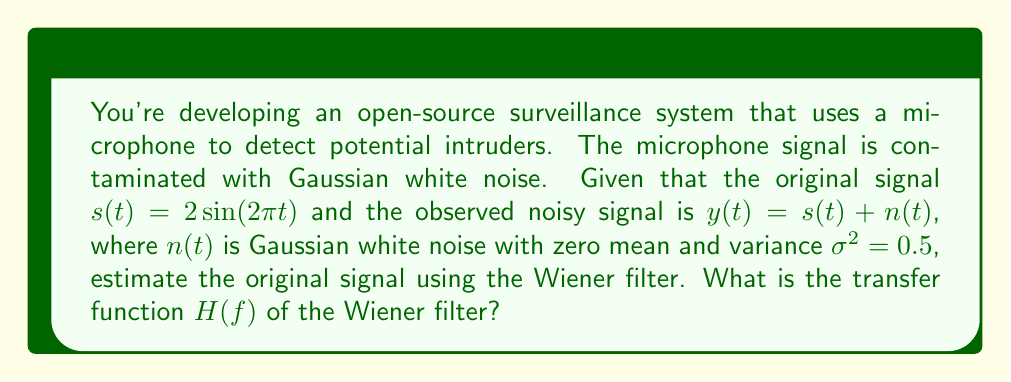Provide a solution to this math problem. To estimate the original signal from noisy sensor data using the Wiener filter, we follow these steps:

1. The Wiener filter's transfer function is given by:

   $$H(f) = \frac{P_s(f)}{P_s(f) + P_n(f)}$$

   where $P_s(f)$ is the power spectral density (PSD) of the original signal, and $P_n(f)$ is the PSD of the noise.

2. For the original signal $s(t) = 2\sin(2\pi t)$, its PSD is:

   $$P_s(f) = 2\delta(f - 1) + 2\delta(f + 1)$$

   where $\delta(f)$ is the Dirac delta function.

3. For Gaussian white noise with variance $\sigma^2 = 0.5$, its PSD is constant across all frequencies:

   $$P_n(f) = \sigma^2 = 0.5$$

4. Substituting these into the Wiener filter equation:

   $$H(f) = \frac{2\delta(f - 1) + 2\delta(f + 1)}{2\delta(f - 1) + 2\delta(f + 1) + 0.5}$$

5. This can be simplified to:

   $$H(f) = \begin{cases}
   \frac{2}{2.5} = 0.8 & \text{for } f = \pm 1 \\
   0 & \text{otherwise}
   \end{cases}$$

Thus, the Wiener filter attenuates the signal at the frequencies of the original signal (±1 Hz) by a factor of 0.8 and completely eliminates all other frequencies.
Answer: $$H(f) = \begin{cases}
0.8 & \text{for } f = \pm 1 \\
0 & \text{otherwise}
\end{cases}$$ 